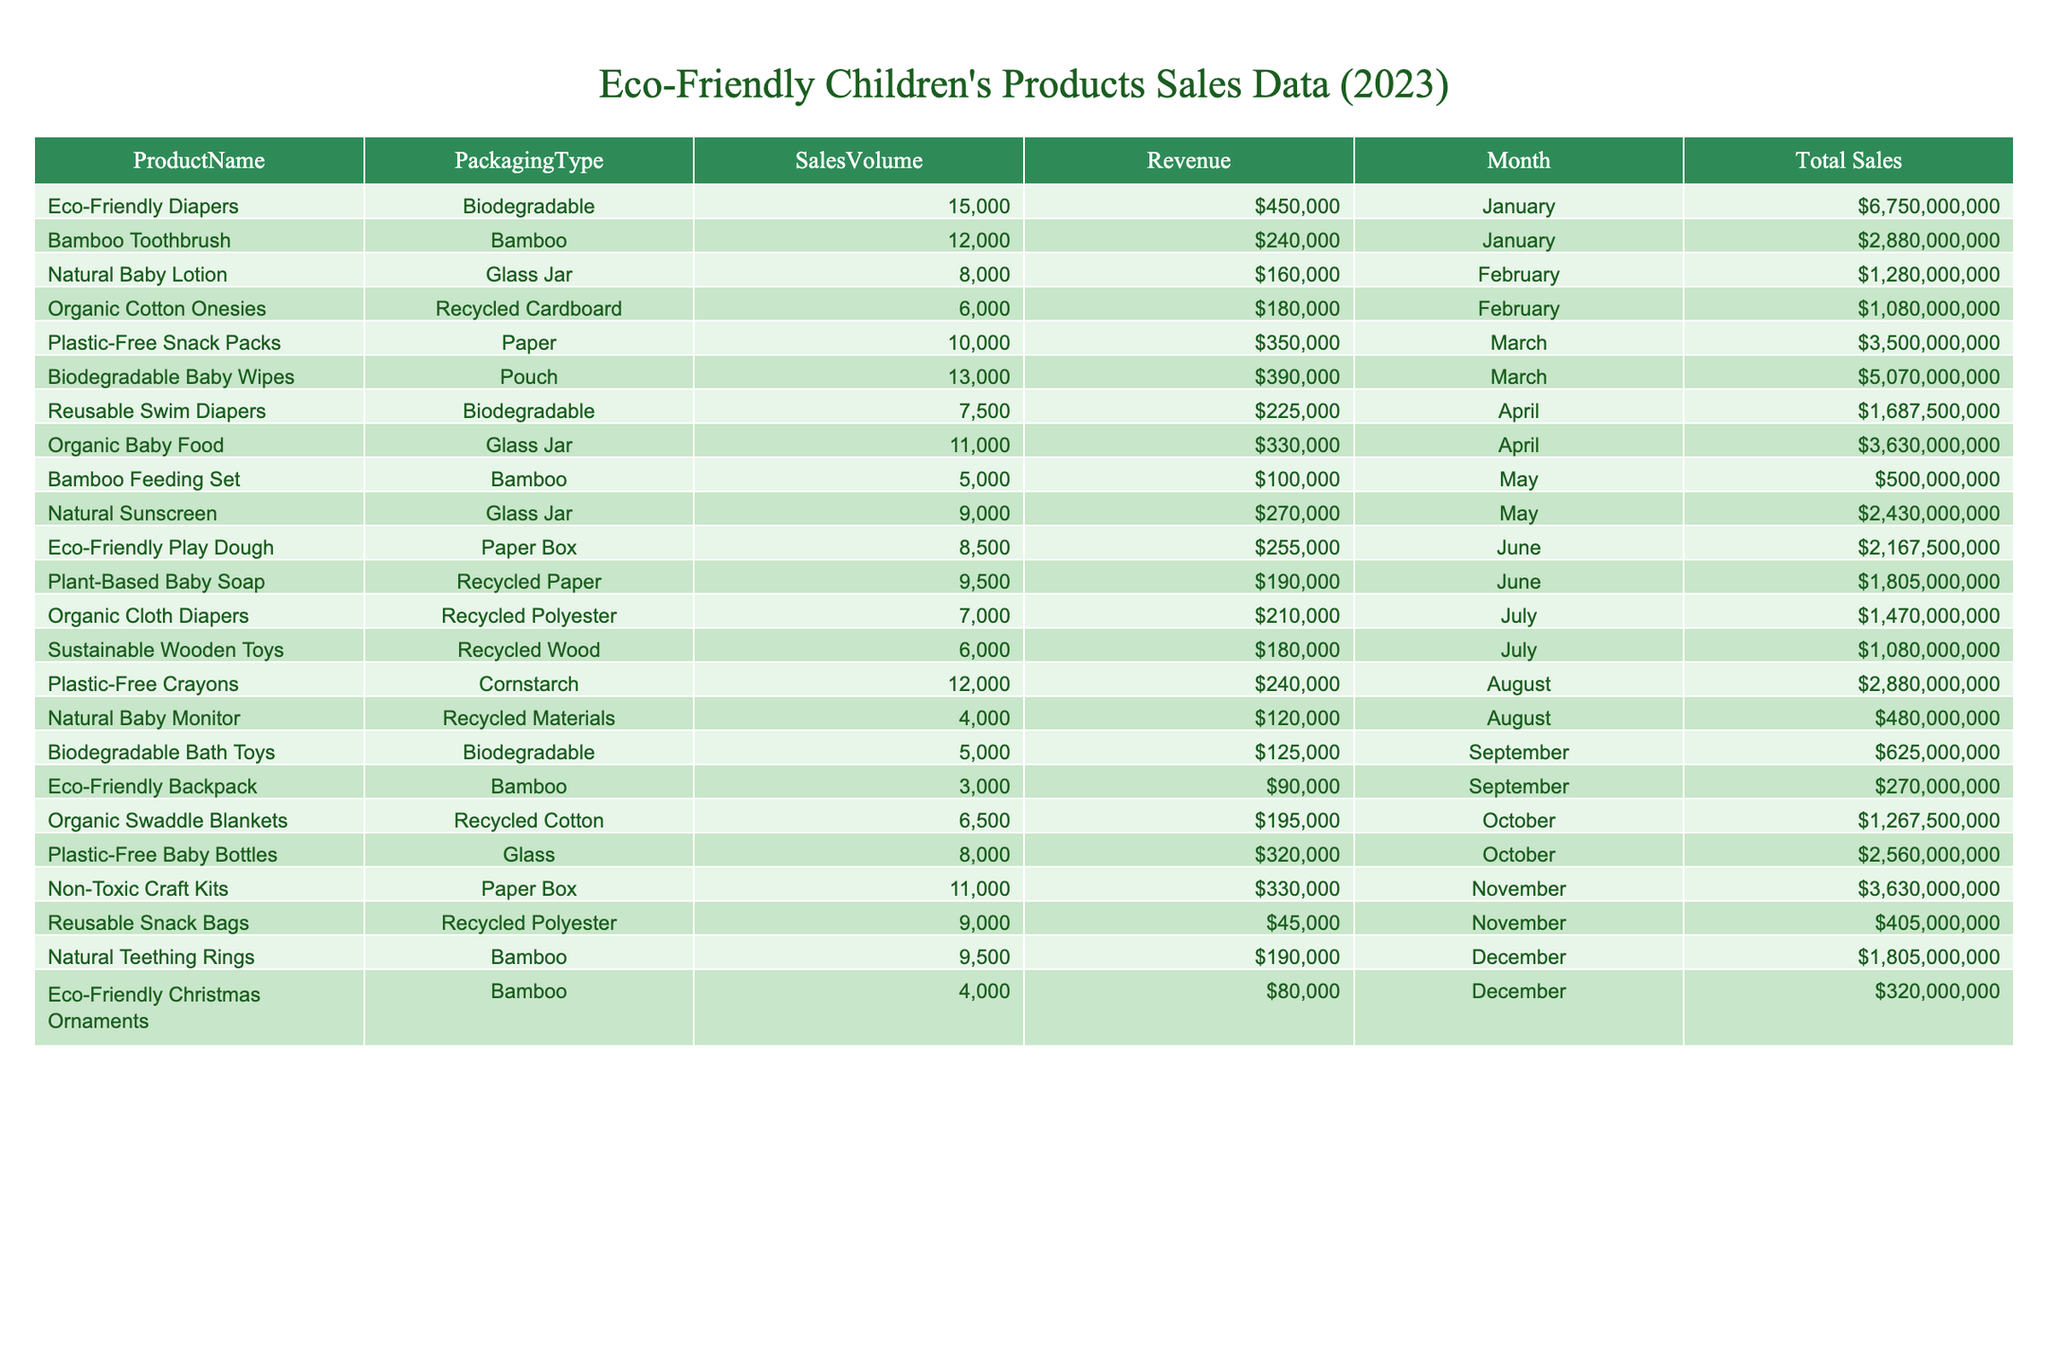What is the highest sales volume recorded among the products? By examining the SalesVolume column, the product with the highest sales volume is Eco-Friendly Diapers, which has a sales volume of 15,000 units.
Answer: 15,000 How much revenue was generated from the Plastic-Free Snack Packs? The table shows the revenue for Plastic-Free Snack Packs is listed under the Revenue column, which indicates it generated $350,000.
Answer: $350,000 What packaging type had the lowest sales volume in December? By checking the December row for all products, we find that Eco-Friendly Christmas Ornaments had the lowest sales volume at 4,000 units.
Answer: 4,000 Which month generated the highest total revenue? To answer this, I will sum the revenue for each month: January ($450,000) + February ($160,000 + $180,000) + March ($350,000 + $390,000) + April ($330,000) + May ($100,000 + $270,000) + June ($255,000 + $190,000) + July ($210,000 + $180,000) + August ($240,000 + $120,000) + September ($125,000 + $90,000) + October ($320,000) + November ($330,000 + $45,000) + December ($190,000 + $80,000). The highest sum comes from March at $740,000.
Answer: March How many more sales were made in March than in October? In March, total sales volume = 10,000 (Snack Packs) + 13,000 (Baby Wipes) = 23,000 units. In October, total sales volume = 8,000 (Baby Bottles) + 6,500 (Swaddle Blankets) = 14,500 units. The difference is 23,000 - 14,500 = 8,500 units more sold in March.
Answer: 8,500 Did the Biodegradable packaging type perform better in terms of sales volume compared to any other single type? In the table, Biodegradable (15,000 + 7,500 + 13,000 + 5,000 = 41,500 units) versus other single types like Glass (8,000 units), Bamboo (15,000 units), and Paper (17,000 units). Biodegradable had the highest total sales volume compared to any other single type.
Answer: Yes What is the average revenue generated per product in July? For July: Organic Cloth Diapers ($210,000) and Sustainable Wooden Toys ($180,000) generate revenues of $210,000 + $180,000 = $390,000 total. There are 2 products, so the average revenue is $390,000 / 2 = $195,000.
Answer: $195,000 How many products used biodegradable packaging? By reviewing the table, the products with biodegradable packaging are Eco-Friendly Diapers, Reusable Swim Diapers, Biodegradable Baby Wipes, and Biodegradable Bath Toys, totaling 4 products.
Answer: 4 